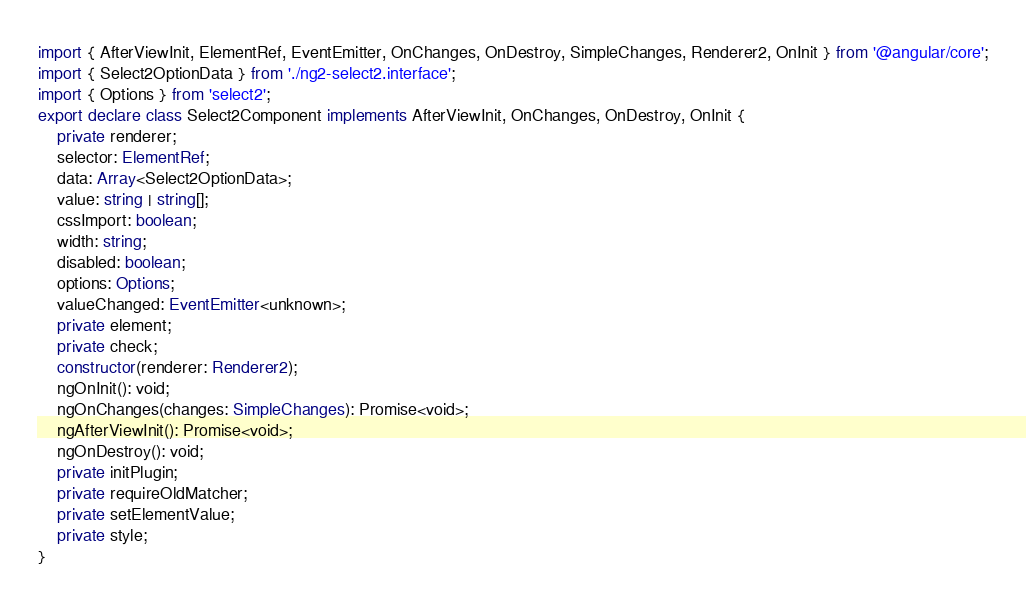<code> <loc_0><loc_0><loc_500><loc_500><_TypeScript_>import { AfterViewInit, ElementRef, EventEmitter, OnChanges, OnDestroy, SimpleChanges, Renderer2, OnInit } from '@angular/core';
import { Select2OptionData } from './ng2-select2.interface';
import { Options } from 'select2';
export declare class Select2Component implements AfterViewInit, OnChanges, OnDestroy, OnInit {
    private renderer;
    selector: ElementRef;
    data: Array<Select2OptionData>;
    value: string | string[];
    cssImport: boolean;
    width: string;
    disabled: boolean;
    options: Options;
    valueChanged: EventEmitter<unknown>;
    private element;
    private check;
    constructor(renderer: Renderer2);
    ngOnInit(): void;
    ngOnChanges(changes: SimpleChanges): Promise<void>;
    ngAfterViewInit(): Promise<void>;
    ngOnDestroy(): void;
    private initPlugin;
    private requireOldMatcher;
    private setElementValue;
    private style;
}
</code> 